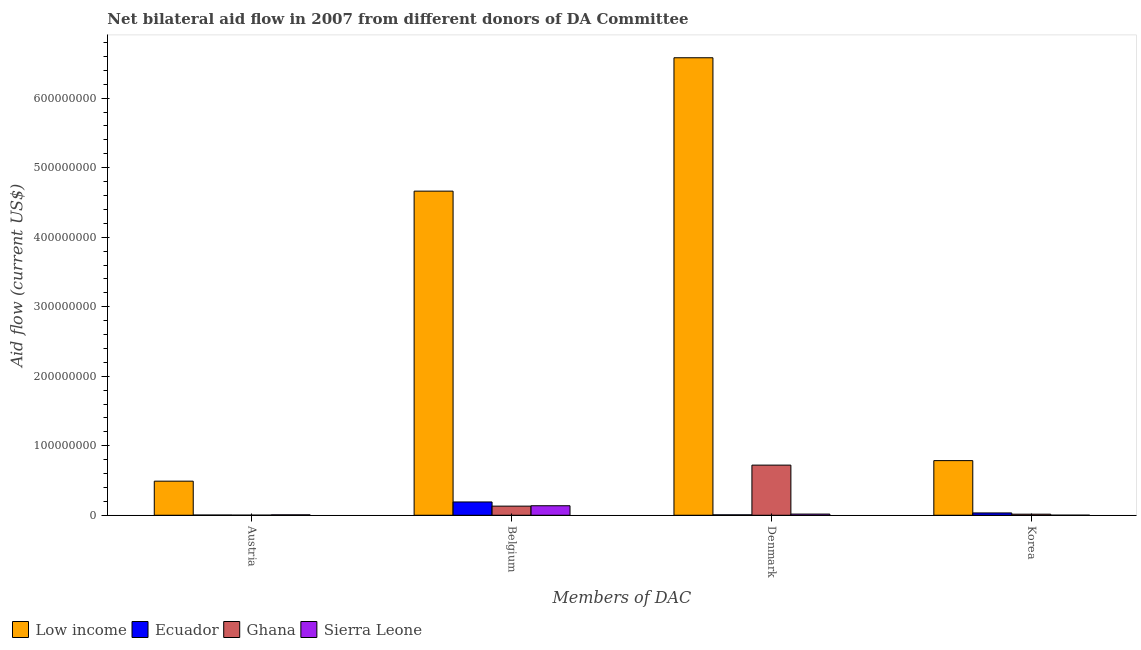How many different coloured bars are there?
Offer a terse response. 4. How many groups of bars are there?
Give a very brief answer. 4. Are the number of bars per tick equal to the number of legend labels?
Your answer should be very brief. Yes. What is the label of the 4th group of bars from the left?
Your answer should be very brief. Korea. What is the amount of aid given by austria in Low income?
Ensure brevity in your answer.  4.90e+07. Across all countries, what is the maximum amount of aid given by belgium?
Give a very brief answer. 4.66e+08. Across all countries, what is the minimum amount of aid given by korea?
Provide a succinct answer. 1.10e+05. In which country was the amount of aid given by denmark minimum?
Offer a terse response. Ecuador. What is the total amount of aid given by korea in the graph?
Provide a succinct answer. 8.36e+07. What is the difference between the amount of aid given by belgium in Ghana and that in Ecuador?
Make the answer very short. -6.00e+06. What is the difference between the amount of aid given by korea in Sierra Leone and the amount of aid given by belgium in Ghana?
Ensure brevity in your answer.  -1.30e+07. What is the average amount of aid given by austria per country?
Offer a terse response. 1.25e+07. What is the difference between the amount of aid given by denmark and amount of aid given by korea in Sierra Leone?
Make the answer very short. 1.60e+06. In how many countries, is the amount of aid given by belgium greater than 220000000 US$?
Your answer should be very brief. 1. What is the ratio of the amount of aid given by belgium in Sierra Leone to that in Ecuador?
Offer a very short reply. 0.72. Is the difference between the amount of aid given by austria in Sierra Leone and Low income greater than the difference between the amount of aid given by denmark in Sierra Leone and Low income?
Ensure brevity in your answer.  Yes. What is the difference between the highest and the second highest amount of aid given by korea?
Your answer should be very brief. 7.53e+07. What is the difference between the highest and the lowest amount of aid given by belgium?
Your response must be concise. 4.53e+08. In how many countries, is the amount of aid given by austria greater than the average amount of aid given by austria taken over all countries?
Keep it short and to the point. 1. What does the 1st bar from the left in Belgium represents?
Offer a very short reply. Low income. What does the 1st bar from the right in Korea represents?
Offer a very short reply. Sierra Leone. Is it the case that in every country, the sum of the amount of aid given by austria and amount of aid given by belgium is greater than the amount of aid given by denmark?
Your answer should be compact. No. Are all the bars in the graph horizontal?
Your response must be concise. No. Where does the legend appear in the graph?
Offer a very short reply. Bottom left. How many legend labels are there?
Make the answer very short. 4. What is the title of the graph?
Provide a short and direct response. Net bilateral aid flow in 2007 from different donors of DA Committee. Does "Kiribati" appear as one of the legend labels in the graph?
Offer a very short reply. No. What is the label or title of the X-axis?
Your response must be concise. Members of DAC. What is the Aid flow (current US$) in Low income in Austria?
Give a very brief answer. 4.90e+07. What is the Aid flow (current US$) of Ghana in Austria?
Your response must be concise. 1.50e+05. What is the Aid flow (current US$) of Sierra Leone in Austria?
Give a very brief answer. 6.00e+05. What is the Aid flow (current US$) in Low income in Belgium?
Provide a succinct answer. 4.66e+08. What is the Aid flow (current US$) in Ecuador in Belgium?
Your response must be concise. 1.91e+07. What is the Aid flow (current US$) in Ghana in Belgium?
Keep it short and to the point. 1.31e+07. What is the Aid flow (current US$) of Sierra Leone in Belgium?
Offer a very short reply. 1.37e+07. What is the Aid flow (current US$) in Low income in Denmark?
Offer a very short reply. 6.58e+08. What is the Aid flow (current US$) in Ghana in Denmark?
Your answer should be compact. 7.21e+07. What is the Aid flow (current US$) in Sierra Leone in Denmark?
Provide a short and direct response. 1.71e+06. What is the Aid flow (current US$) in Low income in Korea?
Offer a very short reply. 7.86e+07. What is the Aid flow (current US$) in Ecuador in Korea?
Ensure brevity in your answer.  3.35e+06. What is the Aid flow (current US$) of Ghana in Korea?
Offer a very short reply. 1.56e+06. What is the Aid flow (current US$) in Sierra Leone in Korea?
Provide a succinct answer. 1.10e+05. Across all Members of DAC, what is the maximum Aid flow (current US$) of Low income?
Provide a succinct answer. 6.58e+08. Across all Members of DAC, what is the maximum Aid flow (current US$) in Ecuador?
Ensure brevity in your answer.  1.91e+07. Across all Members of DAC, what is the maximum Aid flow (current US$) in Ghana?
Keep it short and to the point. 7.21e+07. Across all Members of DAC, what is the maximum Aid flow (current US$) of Sierra Leone?
Your response must be concise. 1.37e+07. Across all Members of DAC, what is the minimum Aid flow (current US$) of Low income?
Provide a succinct answer. 4.90e+07. Across all Members of DAC, what is the minimum Aid flow (current US$) in Ghana?
Provide a succinct answer. 1.50e+05. What is the total Aid flow (current US$) of Low income in the graph?
Your response must be concise. 1.25e+09. What is the total Aid flow (current US$) in Ecuador in the graph?
Keep it short and to the point. 2.34e+07. What is the total Aid flow (current US$) of Ghana in the graph?
Keep it short and to the point. 8.70e+07. What is the total Aid flow (current US$) in Sierra Leone in the graph?
Provide a short and direct response. 1.61e+07. What is the difference between the Aid flow (current US$) in Low income in Austria and that in Belgium?
Your answer should be compact. -4.17e+08. What is the difference between the Aid flow (current US$) in Ecuador in Austria and that in Belgium?
Make the answer very short. -1.88e+07. What is the difference between the Aid flow (current US$) in Ghana in Austria and that in Belgium?
Your answer should be compact. -1.30e+07. What is the difference between the Aid flow (current US$) in Sierra Leone in Austria and that in Belgium?
Make the answer very short. -1.31e+07. What is the difference between the Aid flow (current US$) in Low income in Austria and that in Denmark?
Your answer should be compact. -6.09e+08. What is the difference between the Aid flow (current US$) of Ghana in Austria and that in Denmark?
Your answer should be very brief. -7.20e+07. What is the difference between the Aid flow (current US$) of Sierra Leone in Austria and that in Denmark?
Keep it short and to the point. -1.11e+06. What is the difference between the Aid flow (current US$) in Low income in Austria and that in Korea?
Provide a short and direct response. -2.96e+07. What is the difference between the Aid flow (current US$) in Ecuador in Austria and that in Korea?
Your response must be concise. -3.03e+06. What is the difference between the Aid flow (current US$) in Ghana in Austria and that in Korea?
Make the answer very short. -1.41e+06. What is the difference between the Aid flow (current US$) of Low income in Belgium and that in Denmark?
Ensure brevity in your answer.  -1.92e+08. What is the difference between the Aid flow (current US$) of Ecuador in Belgium and that in Denmark?
Your response must be concise. 1.85e+07. What is the difference between the Aid flow (current US$) in Ghana in Belgium and that in Denmark?
Provide a short and direct response. -5.90e+07. What is the difference between the Aid flow (current US$) of Sierra Leone in Belgium and that in Denmark?
Ensure brevity in your answer.  1.20e+07. What is the difference between the Aid flow (current US$) in Low income in Belgium and that in Korea?
Your answer should be compact. 3.88e+08. What is the difference between the Aid flow (current US$) of Ecuador in Belgium and that in Korea?
Offer a terse response. 1.58e+07. What is the difference between the Aid flow (current US$) of Ghana in Belgium and that in Korea?
Make the answer very short. 1.16e+07. What is the difference between the Aid flow (current US$) in Sierra Leone in Belgium and that in Korea?
Your response must be concise. 1.36e+07. What is the difference between the Aid flow (current US$) in Low income in Denmark and that in Korea?
Your answer should be very brief. 5.80e+08. What is the difference between the Aid flow (current US$) in Ecuador in Denmark and that in Korea?
Make the answer very short. -2.74e+06. What is the difference between the Aid flow (current US$) in Ghana in Denmark and that in Korea?
Provide a succinct answer. 7.06e+07. What is the difference between the Aid flow (current US$) in Sierra Leone in Denmark and that in Korea?
Ensure brevity in your answer.  1.60e+06. What is the difference between the Aid flow (current US$) of Low income in Austria and the Aid flow (current US$) of Ecuador in Belgium?
Ensure brevity in your answer.  2.99e+07. What is the difference between the Aid flow (current US$) in Low income in Austria and the Aid flow (current US$) in Ghana in Belgium?
Your response must be concise. 3.59e+07. What is the difference between the Aid flow (current US$) of Low income in Austria and the Aid flow (current US$) of Sierra Leone in Belgium?
Make the answer very short. 3.54e+07. What is the difference between the Aid flow (current US$) of Ecuador in Austria and the Aid flow (current US$) of Ghana in Belgium?
Ensure brevity in your answer.  -1.28e+07. What is the difference between the Aid flow (current US$) in Ecuador in Austria and the Aid flow (current US$) in Sierra Leone in Belgium?
Give a very brief answer. -1.34e+07. What is the difference between the Aid flow (current US$) of Ghana in Austria and the Aid flow (current US$) of Sierra Leone in Belgium?
Keep it short and to the point. -1.35e+07. What is the difference between the Aid flow (current US$) in Low income in Austria and the Aid flow (current US$) in Ecuador in Denmark?
Keep it short and to the point. 4.84e+07. What is the difference between the Aid flow (current US$) of Low income in Austria and the Aid flow (current US$) of Ghana in Denmark?
Keep it short and to the point. -2.31e+07. What is the difference between the Aid flow (current US$) of Low income in Austria and the Aid flow (current US$) of Sierra Leone in Denmark?
Offer a very short reply. 4.73e+07. What is the difference between the Aid flow (current US$) in Ecuador in Austria and the Aid flow (current US$) in Ghana in Denmark?
Your answer should be compact. -7.18e+07. What is the difference between the Aid flow (current US$) of Ecuador in Austria and the Aid flow (current US$) of Sierra Leone in Denmark?
Offer a terse response. -1.39e+06. What is the difference between the Aid flow (current US$) in Ghana in Austria and the Aid flow (current US$) in Sierra Leone in Denmark?
Ensure brevity in your answer.  -1.56e+06. What is the difference between the Aid flow (current US$) in Low income in Austria and the Aid flow (current US$) in Ecuador in Korea?
Ensure brevity in your answer.  4.57e+07. What is the difference between the Aid flow (current US$) in Low income in Austria and the Aid flow (current US$) in Ghana in Korea?
Your answer should be compact. 4.75e+07. What is the difference between the Aid flow (current US$) of Low income in Austria and the Aid flow (current US$) of Sierra Leone in Korea?
Your answer should be compact. 4.89e+07. What is the difference between the Aid flow (current US$) of Ecuador in Austria and the Aid flow (current US$) of Ghana in Korea?
Give a very brief answer. -1.24e+06. What is the difference between the Aid flow (current US$) in Ghana in Austria and the Aid flow (current US$) in Sierra Leone in Korea?
Give a very brief answer. 4.00e+04. What is the difference between the Aid flow (current US$) of Low income in Belgium and the Aid flow (current US$) of Ecuador in Denmark?
Your answer should be very brief. 4.66e+08. What is the difference between the Aid flow (current US$) of Low income in Belgium and the Aid flow (current US$) of Ghana in Denmark?
Give a very brief answer. 3.94e+08. What is the difference between the Aid flow (current US$) in Low income in Belgium and the Aid flow (current US$) in Sierra Leone in Denmark?
Offer a very short reply. 4.65e+08. What is the difference between the Aid flow (current US$) of Ecuador in Belgium and the Aid flow (current US$) of Ghana in Denmark?
Offer a very short reply. -5.30e+07. What is the difference between the Aid flow (current US$) of Ecuador in Belgium and the Aid flow (current US$) of Sierra Leone in Denmark?
Give a very brief answer. 1.74e+07. What is the difference between the Aid flow (current US$) in Ghana in Belgium and the Aid flow (current US$) in Sierra Leone in Denmark?
Give a very brief answer. 1.14e+07. What is the difference between the Aid flow (current US$) in Low income in Belgium and the Aid flow (current US$) in Ecuador in Korea?
Make the answer very short. 4.63e+08. What is the difference between the Aid flow (current US$) of Low income in Belgium and the Aid flow (current US$) of Ghana in Korea?
Keep it short and to the point. 4.65e+08. What is the difference between the Aid flow (current US$) of Low income in Belgium and the Aid flow (current US$) of Sierra Leone in Korea?
Offer a terse response. 4.66e+08. What is the difference between the Aid flow (current US$) of Ecuador in Belgium and the Aid flow (current US$) of Ghana in Korea?
Offer a very short reply. 1.76e+07. What is the difference between the Aid flow (current US$) in Ecuador in Belgium and the Aid flow (current US$) in Sierra Leone in Korea?
Your answer should be compact. 1.90e+07. What is the difference between the Aid flow (current US$) of Ghana in Belgium and the Aid flow (current US$) of Sierra Leone in Korea?
Provide a short and direct response. 1.30e+07. What is the difference between the Aid flow (current US$) in Low income in Denmark and the Aid flow (current US$) in Ecuador in Korea?
Your answer should be very brief. 6.55e+08. What is the difference between the Aid flow (current US$) in Low income in Denmark and the Aid flow (current US$) in Ghana in Korea?
Ensure brevity in your answer.  6.57e+08. What is the difference between the Aid flow (current US$) in Low income in Denmark and the Aid flow (current US$) in Sierra Leone in Korea?
Ensure brevity in your answer.  6.58e+08. What is the difference between the Aid flow (current US$) of Ecuador in Denmark and the Aid flow (current US$) of Ghana in Korea?
Your response must be concise. -9.50e+05. What is the difference between the Aid flow (current US$) in Ghana in Denmark and the Aid flow (current US$) in Sierra Leone in Korea?
Provide a short and direct response. 7.20e+07. What is the average Aid flow (current US$) of Low income per Members of DAC?
Give a very brief answer. 3.13e+08. What is the average Aid flow (current US$) in Ecuador per Members of DAC?
Your answer should be very brief. 5.86e+06. What is the average Aid flow (current US$) of Ghana per Members of DAC?
Give a very brief answer. 2.17e+07. What is the average Aid flow (current US$) in Sierra Leone per Members of DAC?
Offer a very short reply. 4.03e+06. What is the difference between the Aid flow (current US$) in Low income and Aid flow (current US$) in Ecuador in Austria?
Give a very brief answer. 4.87e+07. What is the difference between the Aid flow (current US$) in Low income and Aid flow (current US$) in Ghana in Austria?
Your response must be concise. 4.89e+07. What is the difference between the Aid flow (current US$) of Low income and Aid flow (current US$) of Sierra Leone in Austria?
Your response must be concise. 4.84e+07. What is the difference between the Aid flow (current US$) of Ecuador and Aid flow (current US$) of Sierra Leone in Austria?
Your answer should be very brief. -2.80e+05. What is the difference between the Aid flow (current US$) of Ghana and Aid flow (current US$) of Sierra Leone in Austria?
Offer a very short reply. -4.50e+05. What is the difference between the Aid flow (current US$) of Low income and Aid flow (current US$) of Ecuador in Belgium?
Give a very brief answer. 4.47e+08. What is the difference between the Aid flow (current US$) in Low income and Aid flow (current US$) in Ghana in Belgium?
Provide a succinct answer. 4.53e+08. What is the difference between the Aid flow (current US$) of Low income and Aid flow (current US$) of Sierra Leone in Belgium?
Provide a succinct answer. 4.53e+08. What is the difference between the Aid flow (current US$) in Ecuador and Aid flow (current US$) in Ghana in Belgium?
Provide a short and direct response. 6.00e+06. What is the difference between the Aid flow (current US$) of Ecuador and Aid flow (current US$) of Sierra Leone in Belgium?
Offer a terse response. 5.45e+06. What is the difference between the Aid flow (current US$) in Ghana and Aid flow (current US$) in Sierra Leone in Belgium?
Your answer should be very brief. -5.50e+05. What is the difference between the Aid flow (current US$) of Low income and Aid flow (current US$) of Ecuador in Denmark?
Ensure brevity in your answer.  6.58e+08. What is the difference between the Aid flow (current US$) of Low income and Aid flow (current US$) of Ghana in Denmark?
Give a very brief answer. 5.86e+08. What is the difference between the Aid flow (current US$) of Low income and Aid flow (current US$) of Sierra Leone in Denmark?
Ensure brevity in your answer.  6.56e+08. What is the difference between the Aid flow (current US$) in Ecuador and Aid flow (current US$) in Ghana in Denmark?
Your response must be concise. -7.15e+07. What is the difference between the Aid flow (current US$) of Ecuador and Aid flow (current US$) of Sierra Leone in Denmark?
Provide a short and direct response. -1.10e+06. What is the difference between the Aid flow (current US$) of Ghana and Aid flow (current US$) of Sierra Leone in Denmark?
Provide a succinct answer. 7.04e+07. What is the difference between the Aid flow (current US$) in Low income and Aid flow (current US$) in Ecuador in Korea?
Offer a very short reply. 7.53e+07. What is the difference between the Aid flow (current US$) of Low income and Aid flow (current US$) of Ghana in Korea?
Make the answer very short. 7.70e+07. What is the difference between the Aid flow (current US$) of Low income and Aid flow (current US$) of Sierra Leone in Korea?
Provide a short and direct response. 7.85e+07. What is the difference between the Aid flow (current US$) in Ecuador and Aid flow (current US$) in Ghana in Korea?
Offer a very short reply. 1.79e+06. What is the difference between the Aid flow (current US$) in Ecuador and Aid flow (current US$) in Sierra Leone in Korea?
Your response must be concise. 3.24e+06. What is the difference between the Aid flow (current US$) of Ghana and Aid flow (current US$) of Sierra Leone in Korea?
Offer a very short reply. 1.45e+06. What is the ratio of the Aid flow (current US$) of Low income in Austria to that in Belgium?
Keep it short and to the point. 0.11. What is the ratio of the Aid flow (current US$) in Ecuador in Austria to that in Belgium?
Make the answer very short. 0.02. What is the ratio of the Aid flow (current US$) of Ghana in Austria to that in Belgium?
Make the answer very short. 0.01. What is the ratio of the Aid flow (current US$) of Sierra Leone in Austria to that in Belgium?
Offer a very short reply. 0.04. What is the ratio of the Aid flow (current US$) in Low income in Austria to that in Denmark?
Offer a terse response. 0.07. What is the ratio of the Aid flow (current US$) in Ecuador in Austria to that in Denmark?
Your response must be concise. 0.52. What is the ratio of the Aid flow (current US$) in Ghana in Austria to that in Denmark?
Your answer should be very brief. 0. What is the ratio of the Aid flow (current US$) of Sierra Leone in Austria to that in Denmark?
Your answer should be very brief. 0.35. What is the ratio of the Aid flow (current US$) of Low income in Austria to that in Korea?
Your answer should be very brief. 0.62. What is the ratio of the Aid flow (current US$) of Ecuador in Austria to that in Korea?
Offer a very short reply. 0.1. What is the ratio of the Aid flow (current US$) of Ghana in Austria to that in Korea?
Provide a succinct answer. 0.1. What is the ratio of the Aid flow (current US$) of Sierra Leone in Austria to that in Korea?
Ensure brevity in your answer.  5.45. What is the ratio of the Aid flow (current US$) of Low income in Belgium to that in Denmark?
Your answer should be compact. 0.71. What is the ratio of the Aid flow (current US$) of Ecuador in Belgium to that in Denmark?
Provide a succinct answer. 31.38. What is the ratio of the Aid flow (current US$) of Ghana in Belgium to that in Denmark?
Your answer should be very brief. 0.18. What is the ratio of the Aid flow (current US$) of Sierra Leone in Belgium to that in Denmark?
Your response must be concise. 8.01. What is the ratio of the Aid flow (current US$) in Low income in Belgium to that in Korea?
Give a very brief answer. 5.93. What is the ratio of the Aid flow (current US$) in Ecuador in Belgium to that in Korea?
Ensure brevity in your answer.  5.71. What is the ratio of the Aid flow (current US$) in Ghana in Belgium to that in Korea?
Keep it short and to the point. 8.42. What is the ratio of the Aid flow (current US$) in Sierra Leone in Belgium to that in Korea?
Keep it short and to the point. 124.45. What is the ratio of the Aid flow (current US$) in Low income in Denmark to that in Korea?
Your response must be concise. 8.37. What is the ratio of the Aid flow (current US$) of Ecuador in Denmark to that in Korea?
Keep it short and to the point. 0.18. What is the ratio of the Aid flow (current US$) in Ghana in Denmark to that in Korea?
Your answer should be compact. 46.24. What is the ratio of the Aid flow (current US$) in Sierra Leone in Denmark to that in Korea?
Provide a short and direct response. 15.55. What is the difference between the highest and the second highest Aid flow (current US$) of Low income?
Your answer should be compact. 1.92e+08. What is the difference between the highest and the second highest Aid flow (current US$) in Ecuador?
Your response must be concise. 1.58e+07. What is the difference between the highest and the second highest Aid flow (current US$) in Ghana?
Give a very brief answer. 5.90e+07. What is the difference between the highest and the second highest Aid flow (current US$) of Sierra Leone?
Offer a very short reply. 1.20e+07. What is the difference between the highest and the lowest Aid flow (current US$) of Low income?
Ensure brevity in your answer.  6.09e+08. What is the difference between the highest and the lowest Aid flow (current US$) in Ecuador?
Your answer should be very brief. 1.88e+07. What is the difference between the highest and the lowest Aid flow (current US$) of Ghana?
Your response must be concise. 7.20e+07. What is the difference between the highest and the lowest Aid flow (current US$) of Sierra Leone?
Your response must be concise. 1.36e+07. 